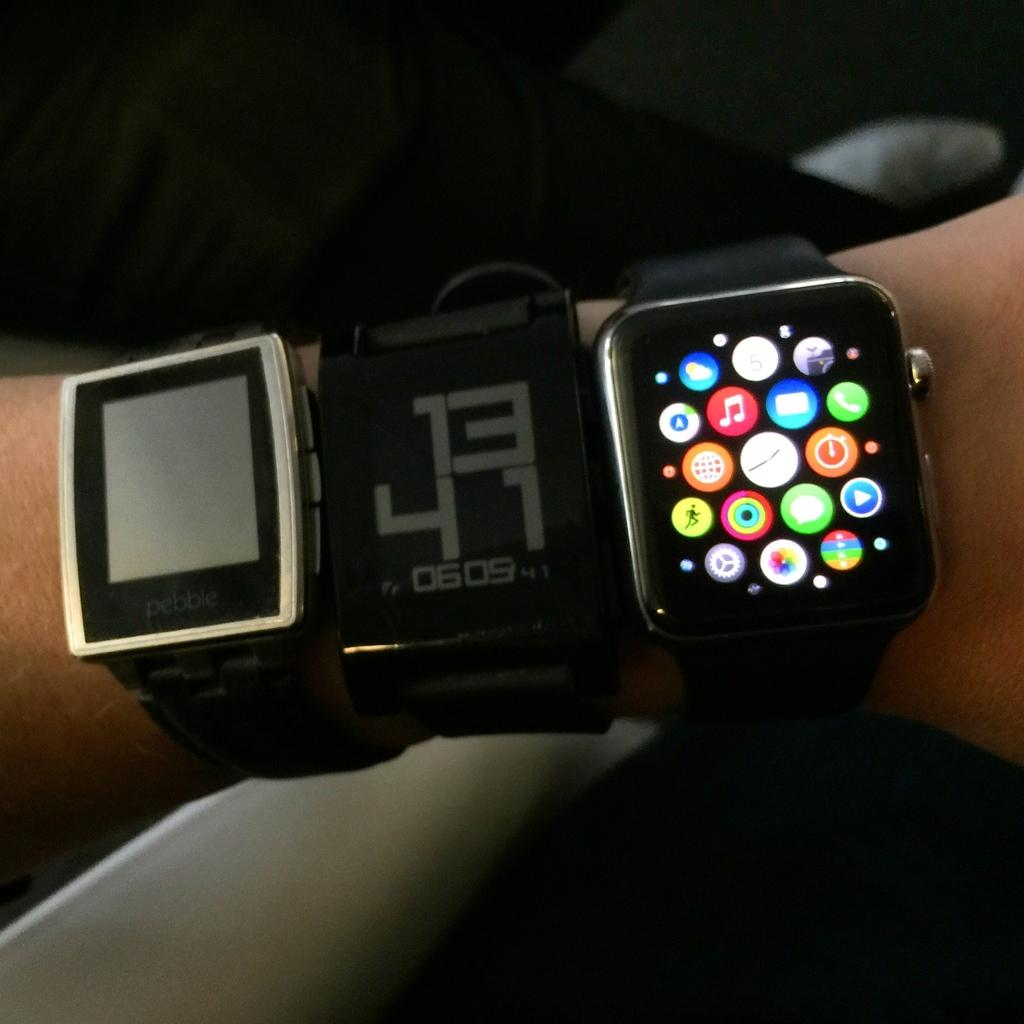<image>
Relay a brief, clear account of the picture shown. A person wearing three smart watch device, of which the middle one reads 1341. 